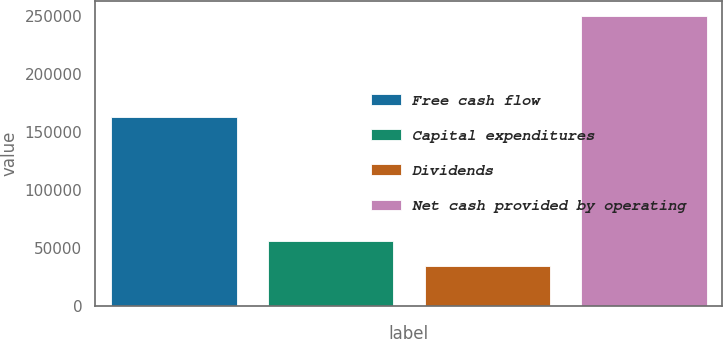Convert chart. <chart><loc_0><loc_0><loc_500><loc_500><bar_chart><fcel>Free cash flow<fcel>Capital expenditures<fcel>Dividends<fcel>Net cash provided by operating<nl><fcel>162361<fcel>56104.9<fcel>34575<fcel>249874<nl></chart> 